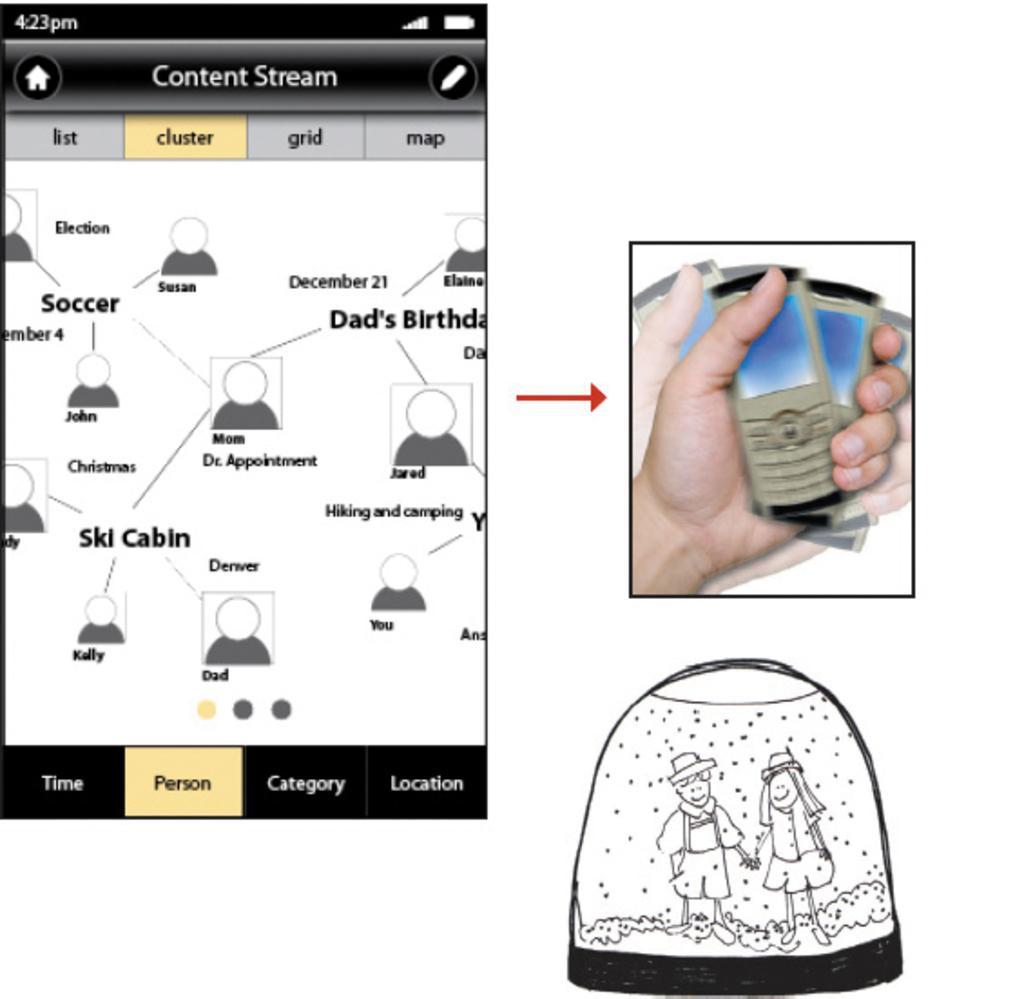How would you summarize this image in a sentence or two? In this image, there are three animated images. The first image is a screenshot of a mobile. In the second image, there are hands of the persons holding mobiles. In the third image, there is a painting of a boy and a girl. Beside the second image, there is a red color mark. And the background is white in color. 